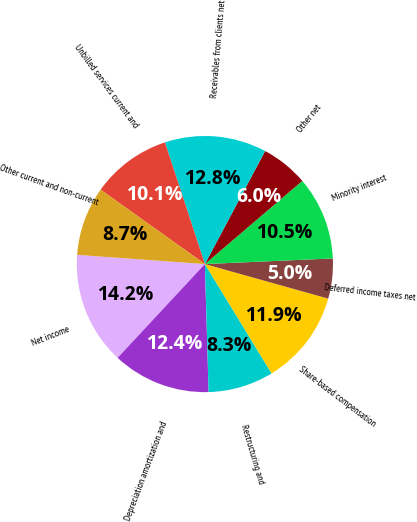Convert chart. <chart><loc_0><loc_0><loc_500><loc_500><pie_chart><fcel>Net income<fcel>Depreciation amortization and<fcel>Restructuring and<fcel>Share-based compensation<fcel>Deferred income taxes net<fcel>Minority interest<fcel>Other net<fcel>Receivables from clients net<fcel>Unbilled services current and<fcel>Other current and non-current<nl><fcel>14.22%<fcel>12.39%<fcel>8.26%<fcel>11.93%<fcel>5.05%<fcel>10.55%<fcel>5.96%<fcel>12.84%<fcel>10.09%<fcel>8.72%<nl></chart> 